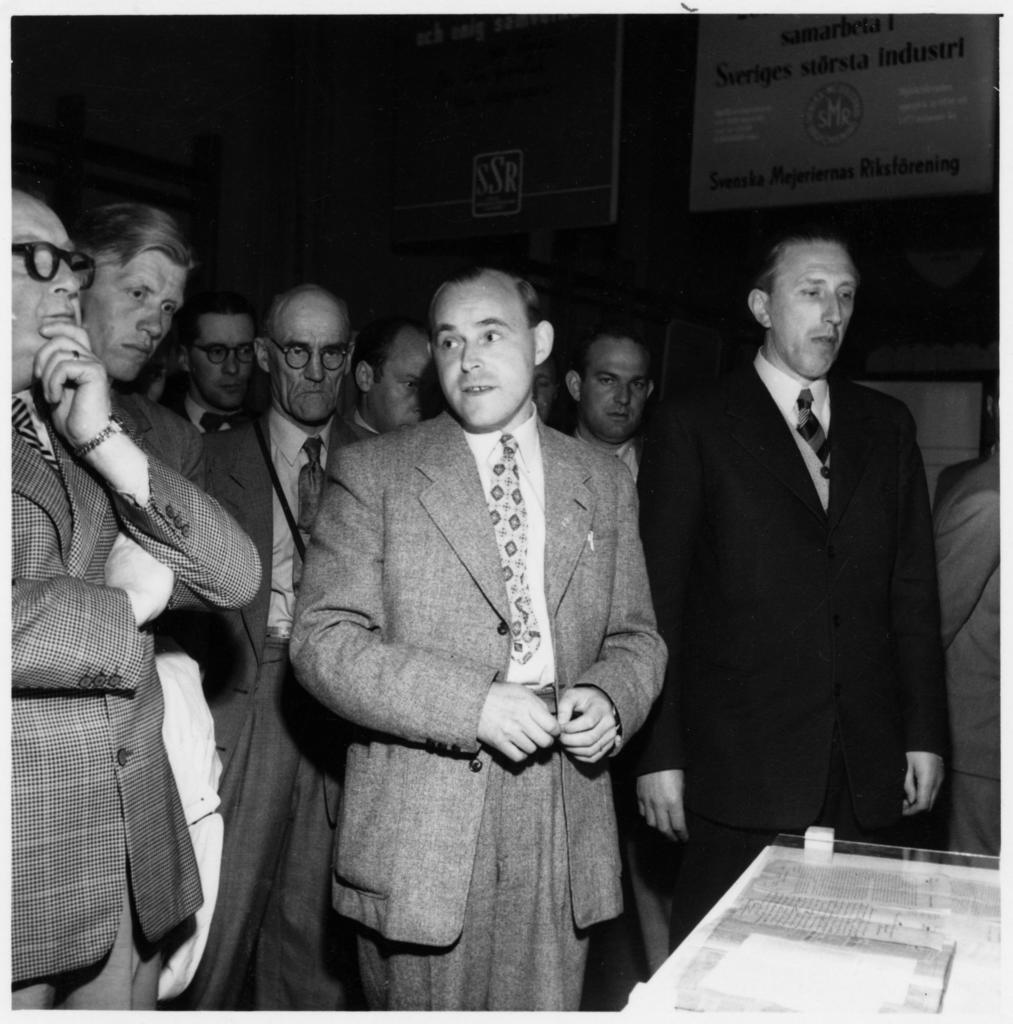Can you describe this image briefly? In the image in the center we can see few people were standing. In front of them,there is a table. On the table,there is a paper. in the background we can see banners,wall and few other objects. 